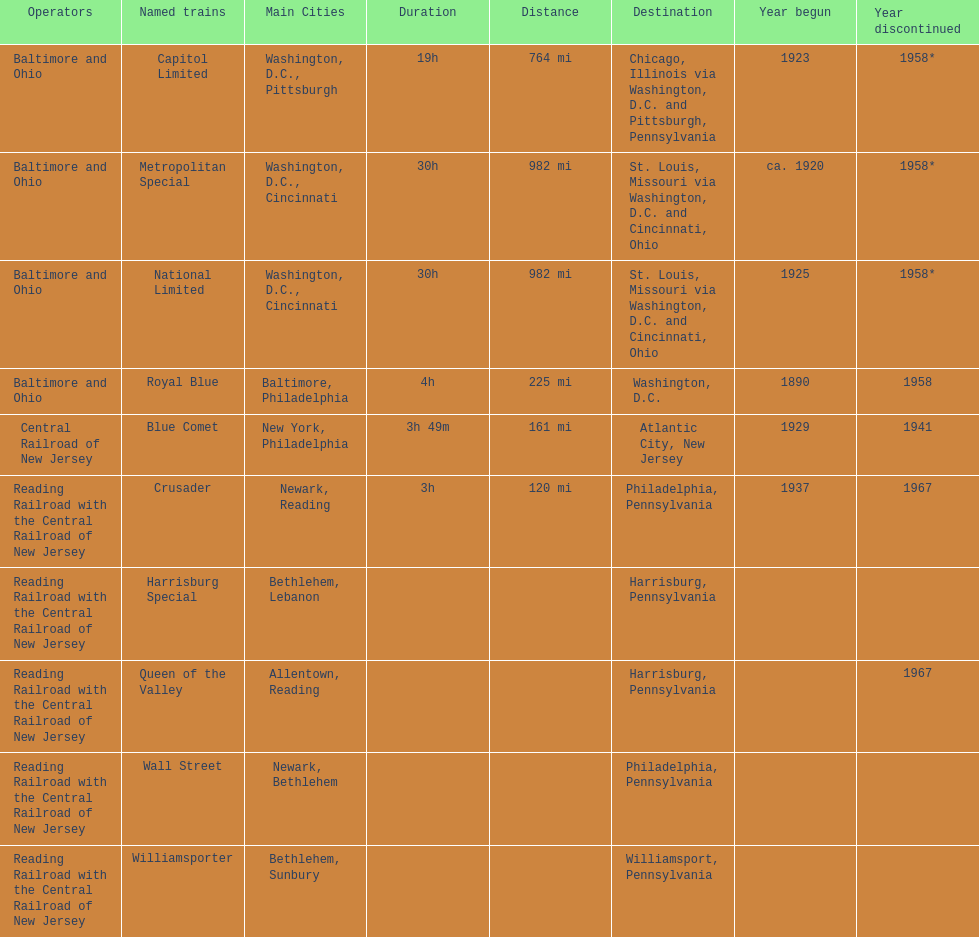Which other traine, other than wall street, had philadelphia as a destination? Crusader. 